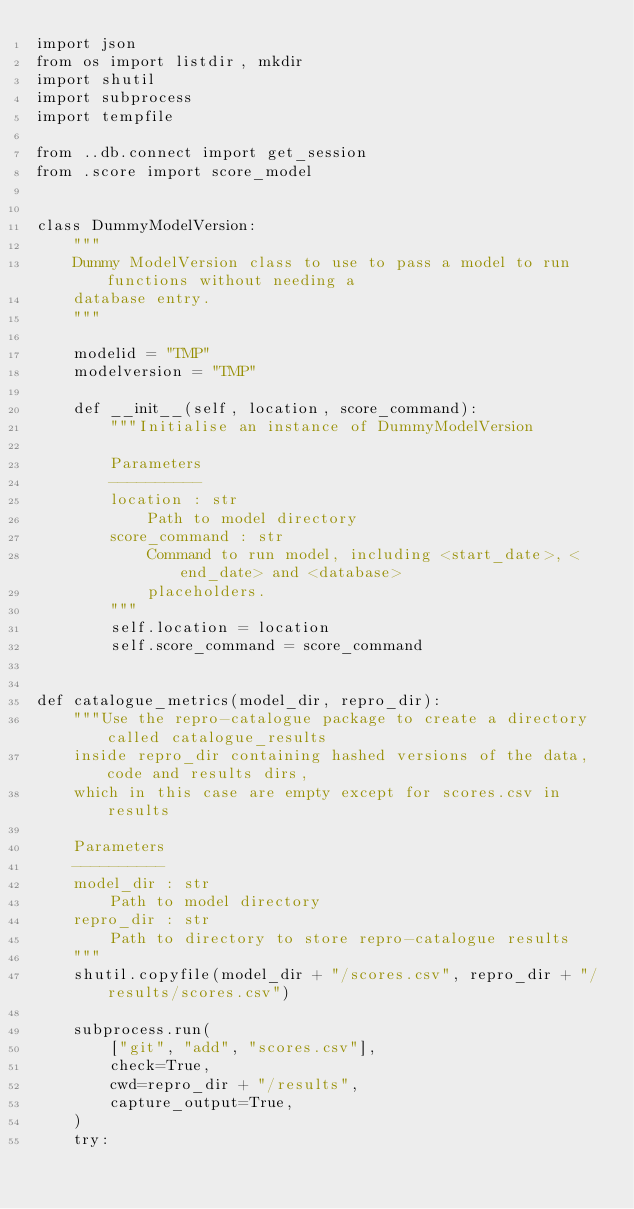Convert code to text. <code><loc_0><loc_0><loc_500><loc_500><_Python_>import json
from os import listdir, mkdir
import shutil
import subprocess
import tempfile

from ..db.connect import get_session
from .score import score_model


class DummyModelVersion:
    """
    Dummy ModelVersion class to use to pass a model to run functions without needing a
    database entry.
    """

    modelid = "TMP"
    modelversion = "TMP"

    def __init__(self, location, score_command):
        """Initialise an instance of DummyModelVersion

        Parameters
        ----------
        location : str
            Path to model directory
        score_command : str
            Command to run model, including <start_date>, <end_date> and <database>
            placeholders.
        """
        self.location = location
        self.score_command = score_command


def catalogue_metrics(model_dir, repro_dir):
    """Use the repro-catalogue package to create a directory called catalogue_results
    inside repro_dir containing hashed versions of the data, code and results dirs,
    which in this case are empty except for scores.csv in results

    Parameters
    ----------
    model_dir : str
        Path to model directory
    repro_dir : str
        Path to directory to store repro-catalogue results
    """
    shutil.copyfile(model_dir + "/scores.csv", repro_dir + "/results/scores.csv")

    subprocess.run(
        ["git", "add", "scores.csv"],
        check=True,
        cwd=repro_dir + "/results",
        capture_output=True,
    )
    try:</code> 